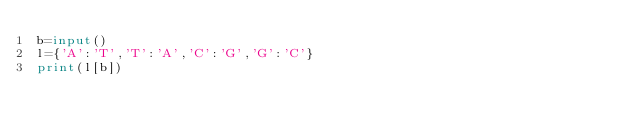<code> <loc_0><loc_0><loc_500><loc_500><_Python_>b=input()
l={'A':'T','T':'A','C':'G','G':'C'}
print(l[b])</code> 